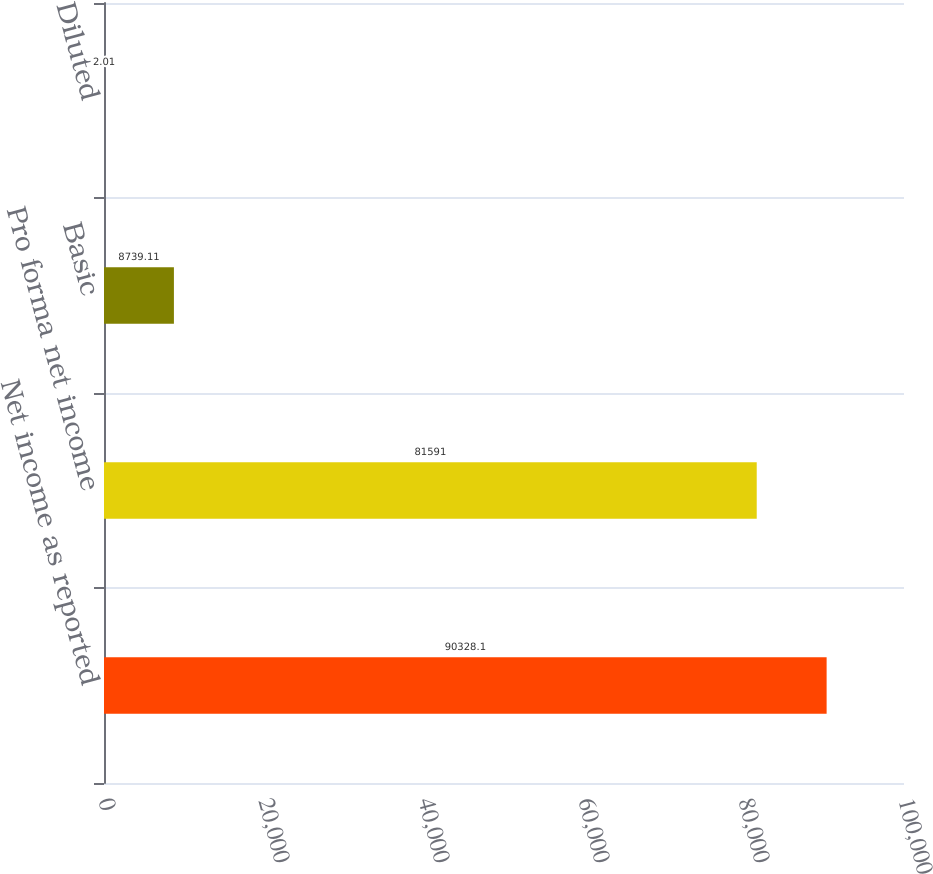<chart> <loc_0><loc_0><loc_500><loc_500><bar_chart><fcel>Net income as reported<fcel>Pro forma net income<fcel>Basic<fcel>Diluted<nl><fcel>90328.1<fcel>81591<fcel>8739.11<fcel>2.01<nl></chart> 